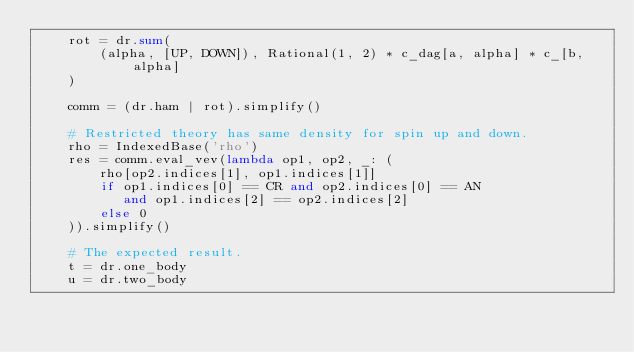Convert code to text. <code><loc_0><loc_0><loc_500><loc_500><_Python_>    rot = dr.sum(
        (alpha, [UP, DOWN]), Rational(1, 2) * c_dag[a, alpha] * c_[b, alpha]
    )

    comm = (dr.ham | rot).simplify()

    # Restricted theory has same density for spin up and down.
    rho = IndexedBase('rho')
    res = comm.eval_vev(lambda op1, op2, _: (
        rho[op2.indices[1], op1.indices[1]]
        if op1.indices[0] == CR and op2.indices[0] == AN
           and op1.indices[2] == op2.indices[2]
        else 0
    )).simplify()

    # The expected result.
    t = dr.one_body
    u = dr.two_body
</code> 